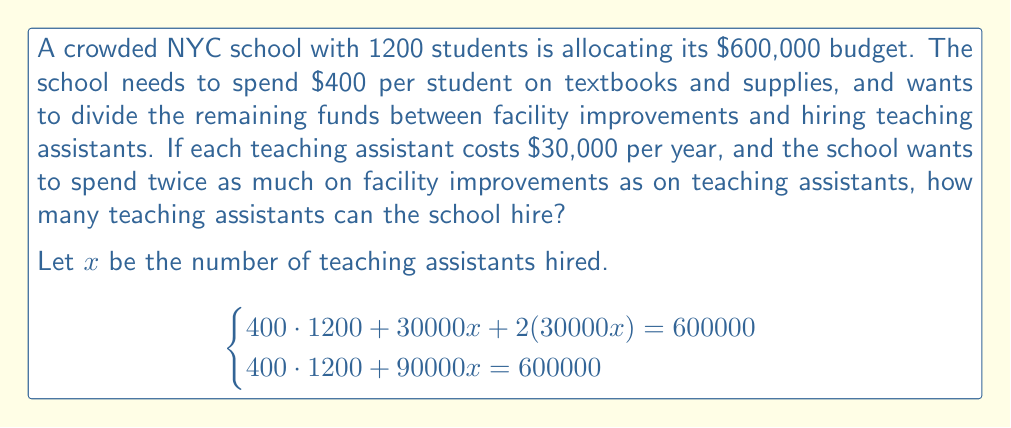Can you answer this question? 1. Calculate the cost of textbooks and supplies:
   $400 \cdot 1200 = 480000$

2. Set up the equation:
   $480000 + 90000x = 600000$

3. Subtract 480000 from both sides:
   $90000x = 120000$

4. Divide both sides by 90000:
   $x = \frac{120000}{90000} = \frac{4}{3} = 1.33333...$

5. Since we can't hire a fractional number of teaching assistants, we round down to the nearest whole number.

Therefore, the school can hire 1 teaching assistant.
Answer: 1 teaching assistant 